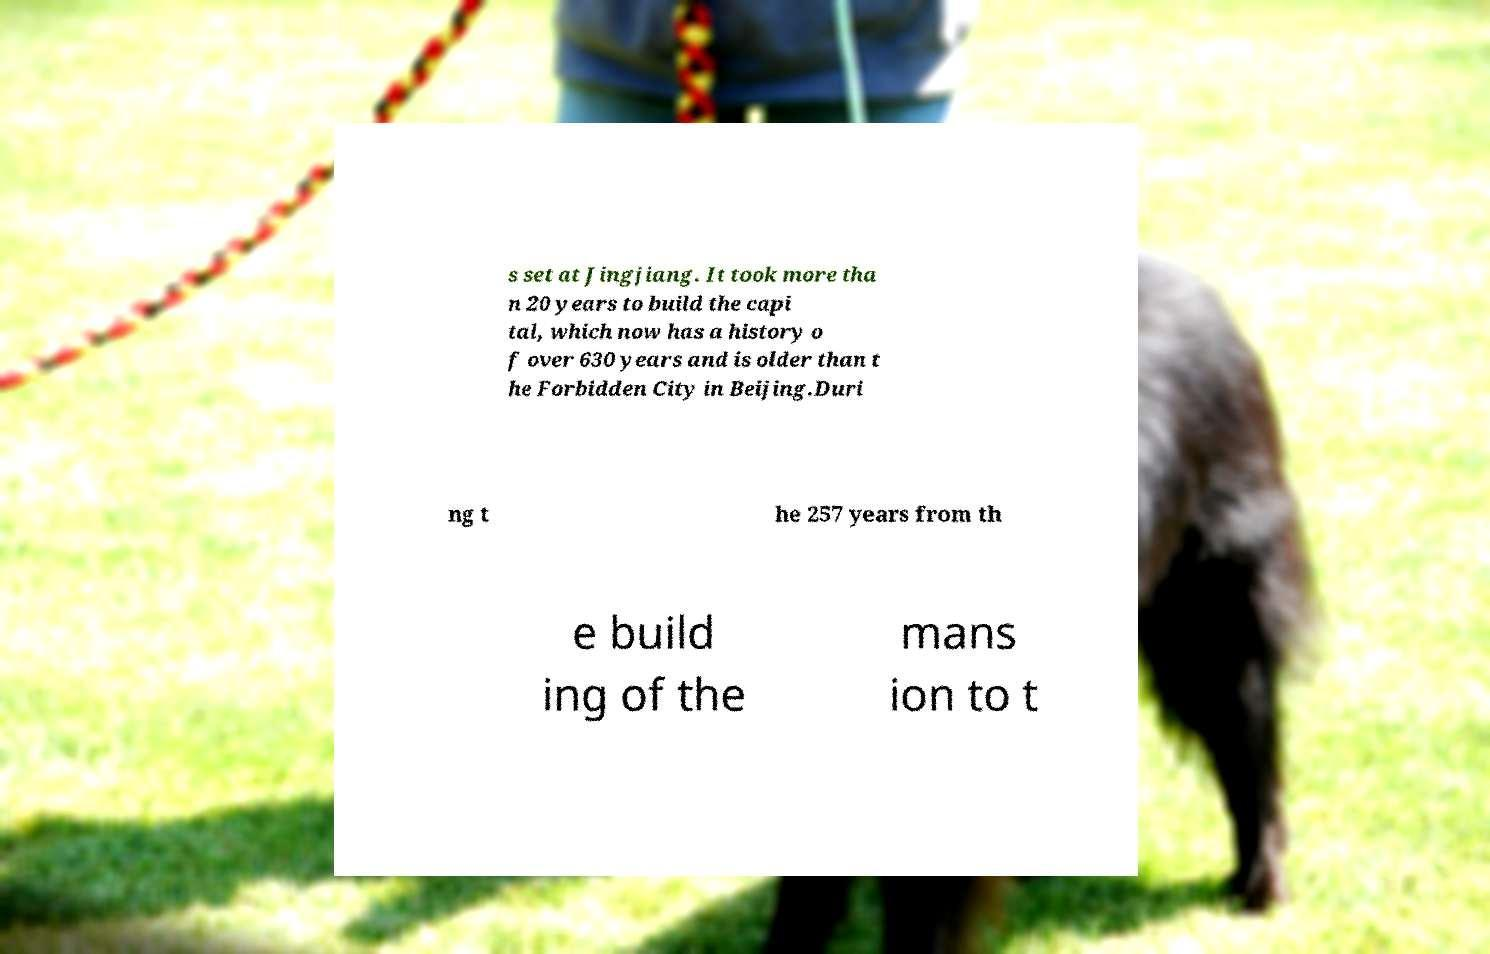Please identify and transcribe the text found in this image. s set at Jingjiang. It took more tha n 20 years to build the capi tal, which now has a history o f over 630 years and is older than t he Forbidden City in Beijing.Duri ng t he 257 years from th e build ing of the mans ion to t 